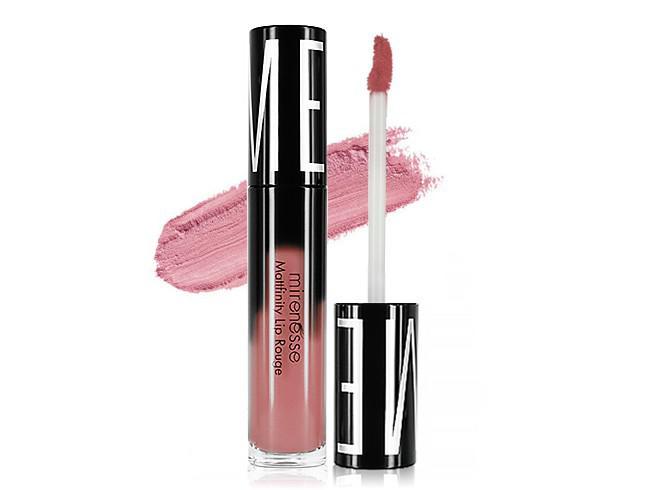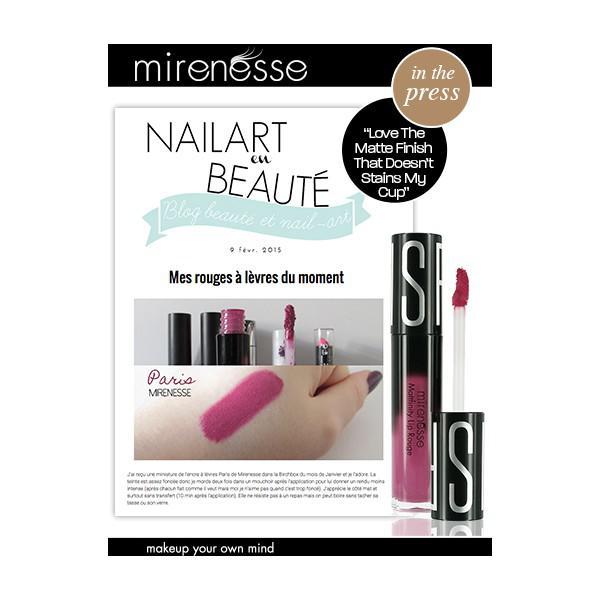The first image is the image on the left, the second image is the image on the right. Evaluate the accuracy of this statement regarding the images: "there is exactly one pair of lips in the image on the left". Is it true? Answer yes or no. No. The first image is the image on the left, the second image is the image on the right. Assess this claim about the two images: "Left image shows a pink lipstick with cap on, and image of glossy lips.". Correct or not? Answer yes or no. No. 